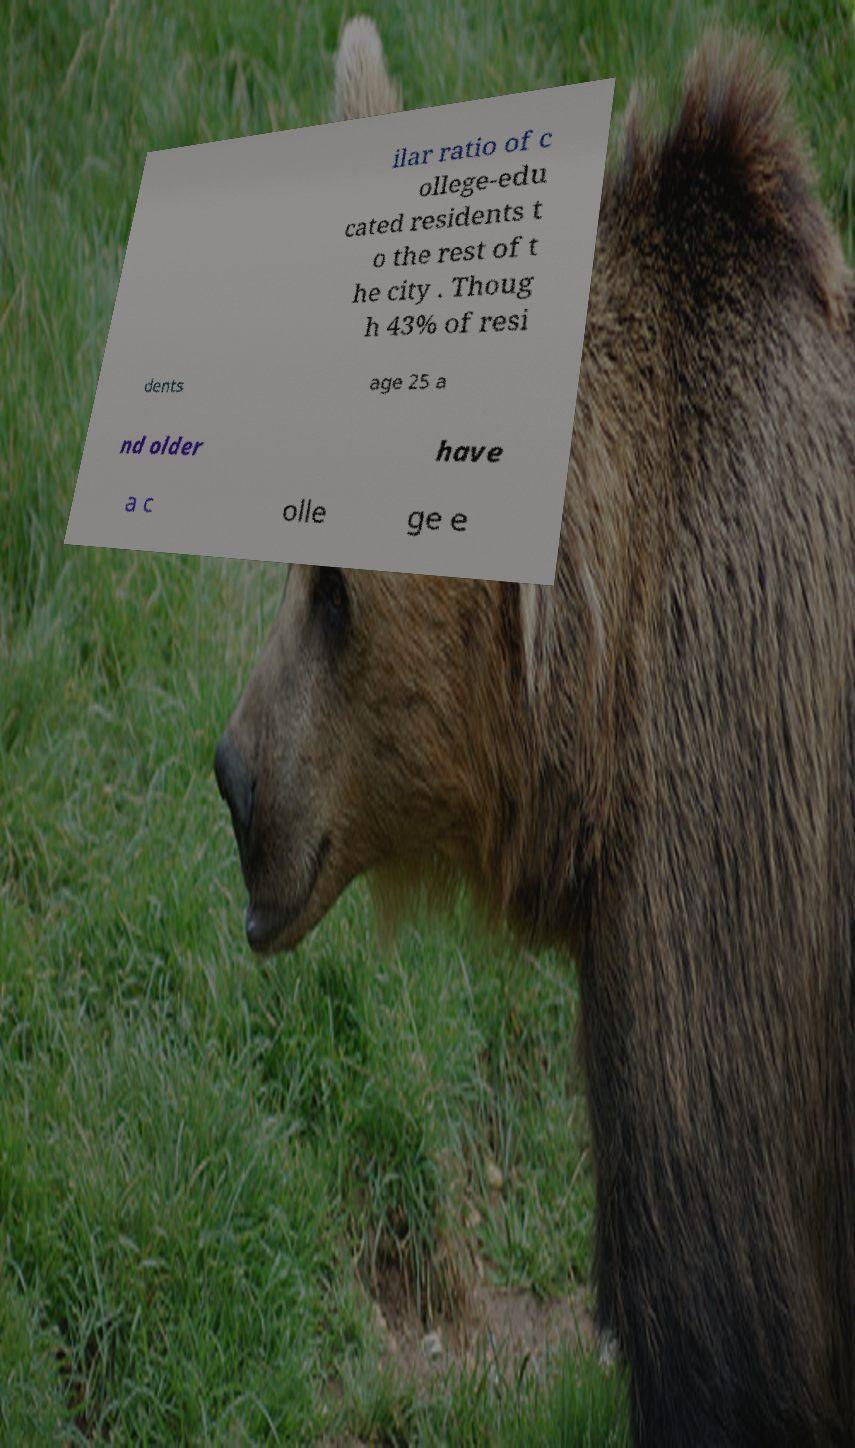I need the written content from this picture converted into text. Can you do that? ilar ratio of c ollege-edu cated residents t o the rest of t he city . Thoug h 43% of resi dents age 25 a nd older have a c olle ge e 